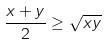Convert formula to latex. <formula><loc_0><loc_0><loc_500><loc_500>\frac { x + y } { 2 } \geq \sqrt { x y }</formula> 